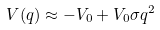Convert formula to latex. <formula><loc_0><loc_0><loc_500><loc_500>V ( q ) \approx - V _ { 0 } + V _ { 0 } \sigma q ^ { 2 }</formula> 